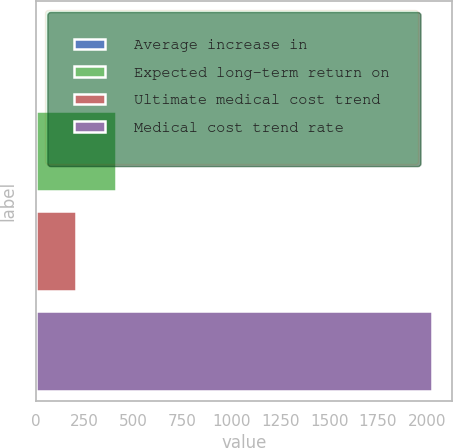<chart> <loc_0><loc_0><loc_500><loc_500><bar_chart><fcel>Average increase in<fcel>Expected long-term return on<fcel>Ultimate medical cost trend<fcel>Medical cost trend rate<nl><fcel>3.5<fcel>408.4<fcel>205.95<fcel>2028<nl></chart> 